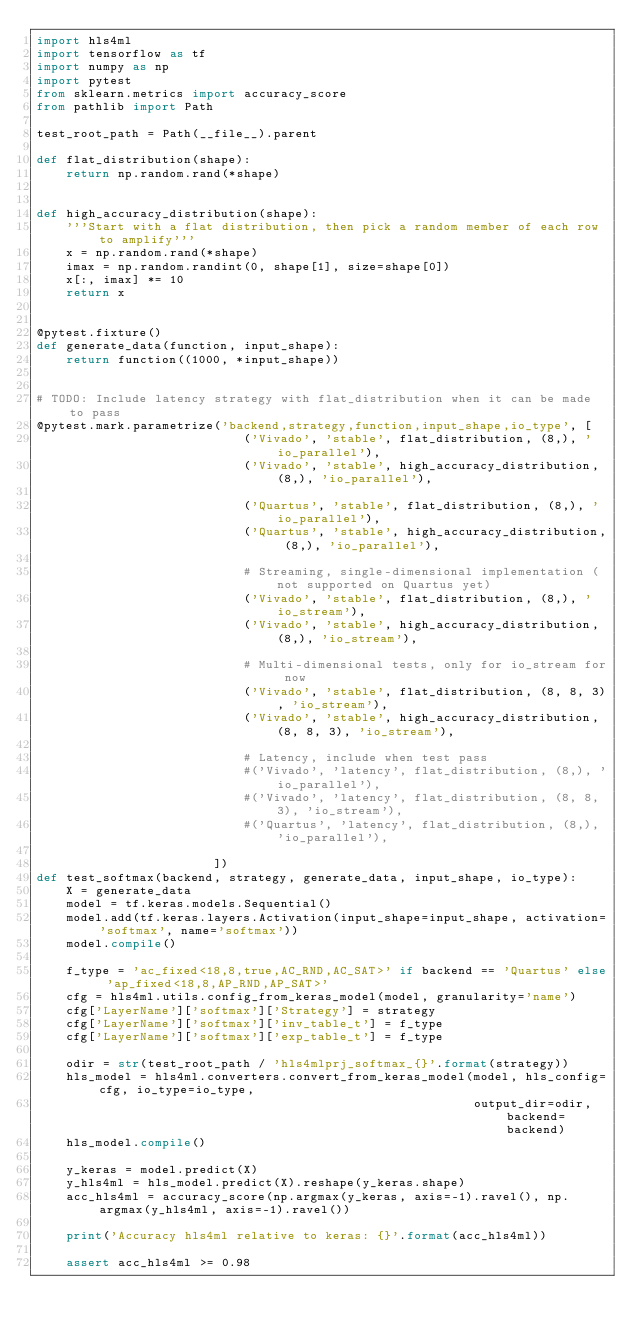<code> <loc_0><loc_0><loc_500><loc_500><_Python_>import hls4ml
import tensorflow as tf
import numpy as np
import pytest
from sklearn.metrics import accuracy_score
from pathlib import Path

test_root_path = Path(__file__).parent

def flat_distribution(shape):
    return np.random.rand(*shape)


def high_accuracy_distribution(shape):
    '''Start with a flat distribution, then pick a random member of each row to amplify'''
    x = np.random.rand(*shape)
    imax = np.random.randint(0, shape[1], size=shape[0])
    x[:, imax] *= 10
    return x


@pytest.fixture()
def generate_data(function, input_shape):
    return function((1000, *input_shape))


# TODO: Include latency strategy with flat_distribution when it can be made to pass
@pytest.mark.parametrize('backend,strategy,function,input_shape,io_type', [   
                            ('Vivado', 'stable', flat_distribution, (8,), 'io_parallel'),
                            ('Vivado', 'stable', high_accuracy_distribution, (8,), 'io_parallel'),
                            
                            ('Quartus', 'stable', flat_distribution, (8,), 'io_parallel'),
                            ('Quartus', 'stable', high_accuracy_distribution, (8,), 'io_parallel'),

                            # Streaming, single-dimensional implementation (not supported on Quartus yet)
                            ('Vivado', 'stable', flat_distribution, (8,), 'io_stream'),
                            ('Vivado', 'stable', high_accuracy_distribution, (8,), 'io_stream'),
                            
                            # Multi-dimensional tests, only for io_stream for now
                            ('Vivado', 'stable', flat_distribution, (8, 8, 3), 'io_stream'),
                            ('Vivado', 'stable', high_accuracy_distribution, (8, 8, 3), 'io_stream'),

                            # Latency, include when test pass
                            #('Vivado', 'latency', flat_distribution, (8,), 'io_parallel'),
                            #('Vivado', 'latency', flat_distribution, (8, 8, 3), 'io_stream'),
                            #('Quartus', 'latency', flat_distribution, (8,), 'io_parallel'),
                            
                        ])
def test_softmax(backend, strategy, generate_data, input_shape, io_type):
    X = generate_data
    model = tf.keras.models.Sequential()
    model.add(tf.keras.layers.Activation(input_shape=input_shape, activation='softmax', name='softmax'))
    model.compile()
    
    f_type = 'ac_fixed<18,8,true,AC_RND,AC_SAT>' if backend == 'Quartus' else 'ap_fixed<18,8,AP_RND,AP_SAT>'
    cfg = hls4ml.utils.config_from_keras_model(model, granularity='name')
    cfg['LayerName']['softmax']['Strategy'] = strategy
    cfg['LayerName']['softmax']['inv_table_t'] = f_type
    cfg['LayerName']['softmax']['exp_table_t'] = f_type
    
    odir = str(test_root_path / 'hls4mlprj_softmax_{}'.format(strategy))
    hls_model = hls4ml.converters.convert_from_keras_model(model, hls_config=cfg, io_type=io_type,
                                                           output_dir=odir, backend=backend)
    hls_model.compile()
   
    y_keras = model.predict(X)
    y_hls4ml = hls_model.predict(X).reshape(y_keras.shape)
    acc_hls4ml = accuracy_score(np.argmax(y_keras, axis=-1).ravel(), np.argmax(y_hls4ml, axis=-1).ravel())

    print('Accuracy hls4ml relative to keras: {}'.format(acc_hls4ml))

    assert acc_hls4ml >= 0.98
</code> 